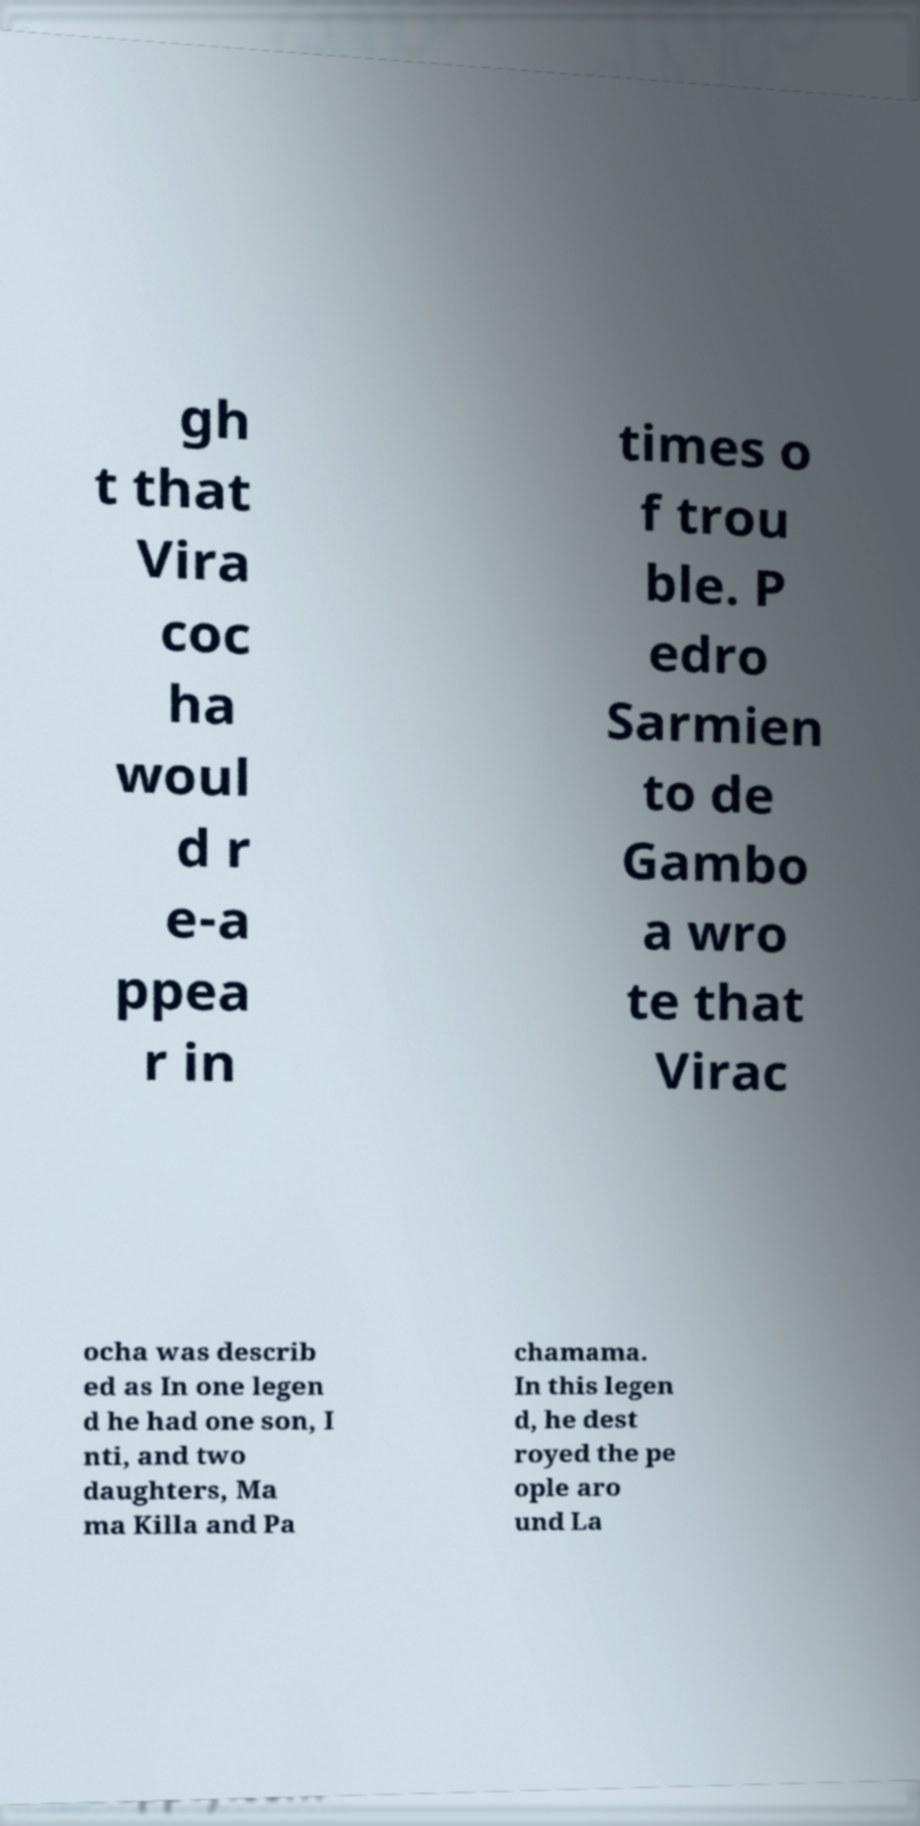There's text embedded in this image that I need extracted. Can you transcribe it verbatim? gh t that Vira coc ha woul d r e-a ppea r in times o f trou ble. P edro Sarmien to de Gambo a wro te that Virac ocha was describ ed as In one legen d he had one son, I nti, and two daughters, Ma ma Killa and Pa chamama. In this legen d, he dest royed the pe ople aro und La 